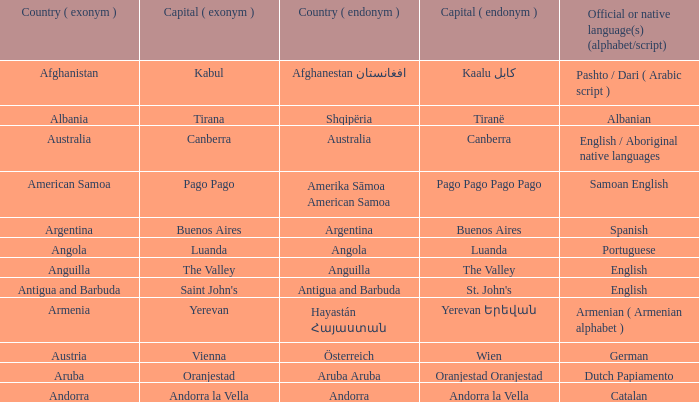Would you mind parsing the complete table? {'header': ['Country ( exonym )', 'Capital ( exonym )', 'Country ( endonym )', 'Capital ( endonym )', 'Official or native language(s) (alphabet/script)'], 'rows': [['Afghanistan', 'Kabul', 'Afghanestan افغانستان', 'Kaalu كابل', 'Pashto / Dari ( Arabic script )'], ['Albania', 'Tirana', 'Shqipëria', 'Tiranë', 'Albanian'], ['Australia', 'Canberra', 'Australia', 'Canberra', 'English / Aboriginal native languages'], ['American Samoa', 'Pago Pago', 'Amerika Sāmoa American Samoa', 'Pago Pago Pago Pago', 'Samoan English'], ['Argentina', 'Buenos Aires', 'Argentina', 'Buenos Aires', 'Spanish'], ['Angola', 'Luanda', 'Angola', 'Luanda', 'Portuguese'], ['Anguilla', 'The Valley', 'Anguilla', 'The Valley', 'English'], ['Antigua and Barbuda', "Saint John's", 'Antigua and Barbuda', "St. John's", 'English'], ['Armenia', 'Yerevan', 'Hayastán Հայաստան', 'Yerevan Երեվան', 'Armenian ( Armenian alphabet )'], ['Austria', 'Vienna', 'Österreich', 'Wien', 'German'], ['Aruba', 'Oranjestad', 'Aruba Aruba', 'Oranjestad Oranjestad', 'Dutch Papiamento'], ['Andorra', 'Andorra la Vella', 'Andorra', 'Andorra la Vella', 'Catalan']]} What is the English name of the country whose official native language is Dutch Papiamento? Aruba. 